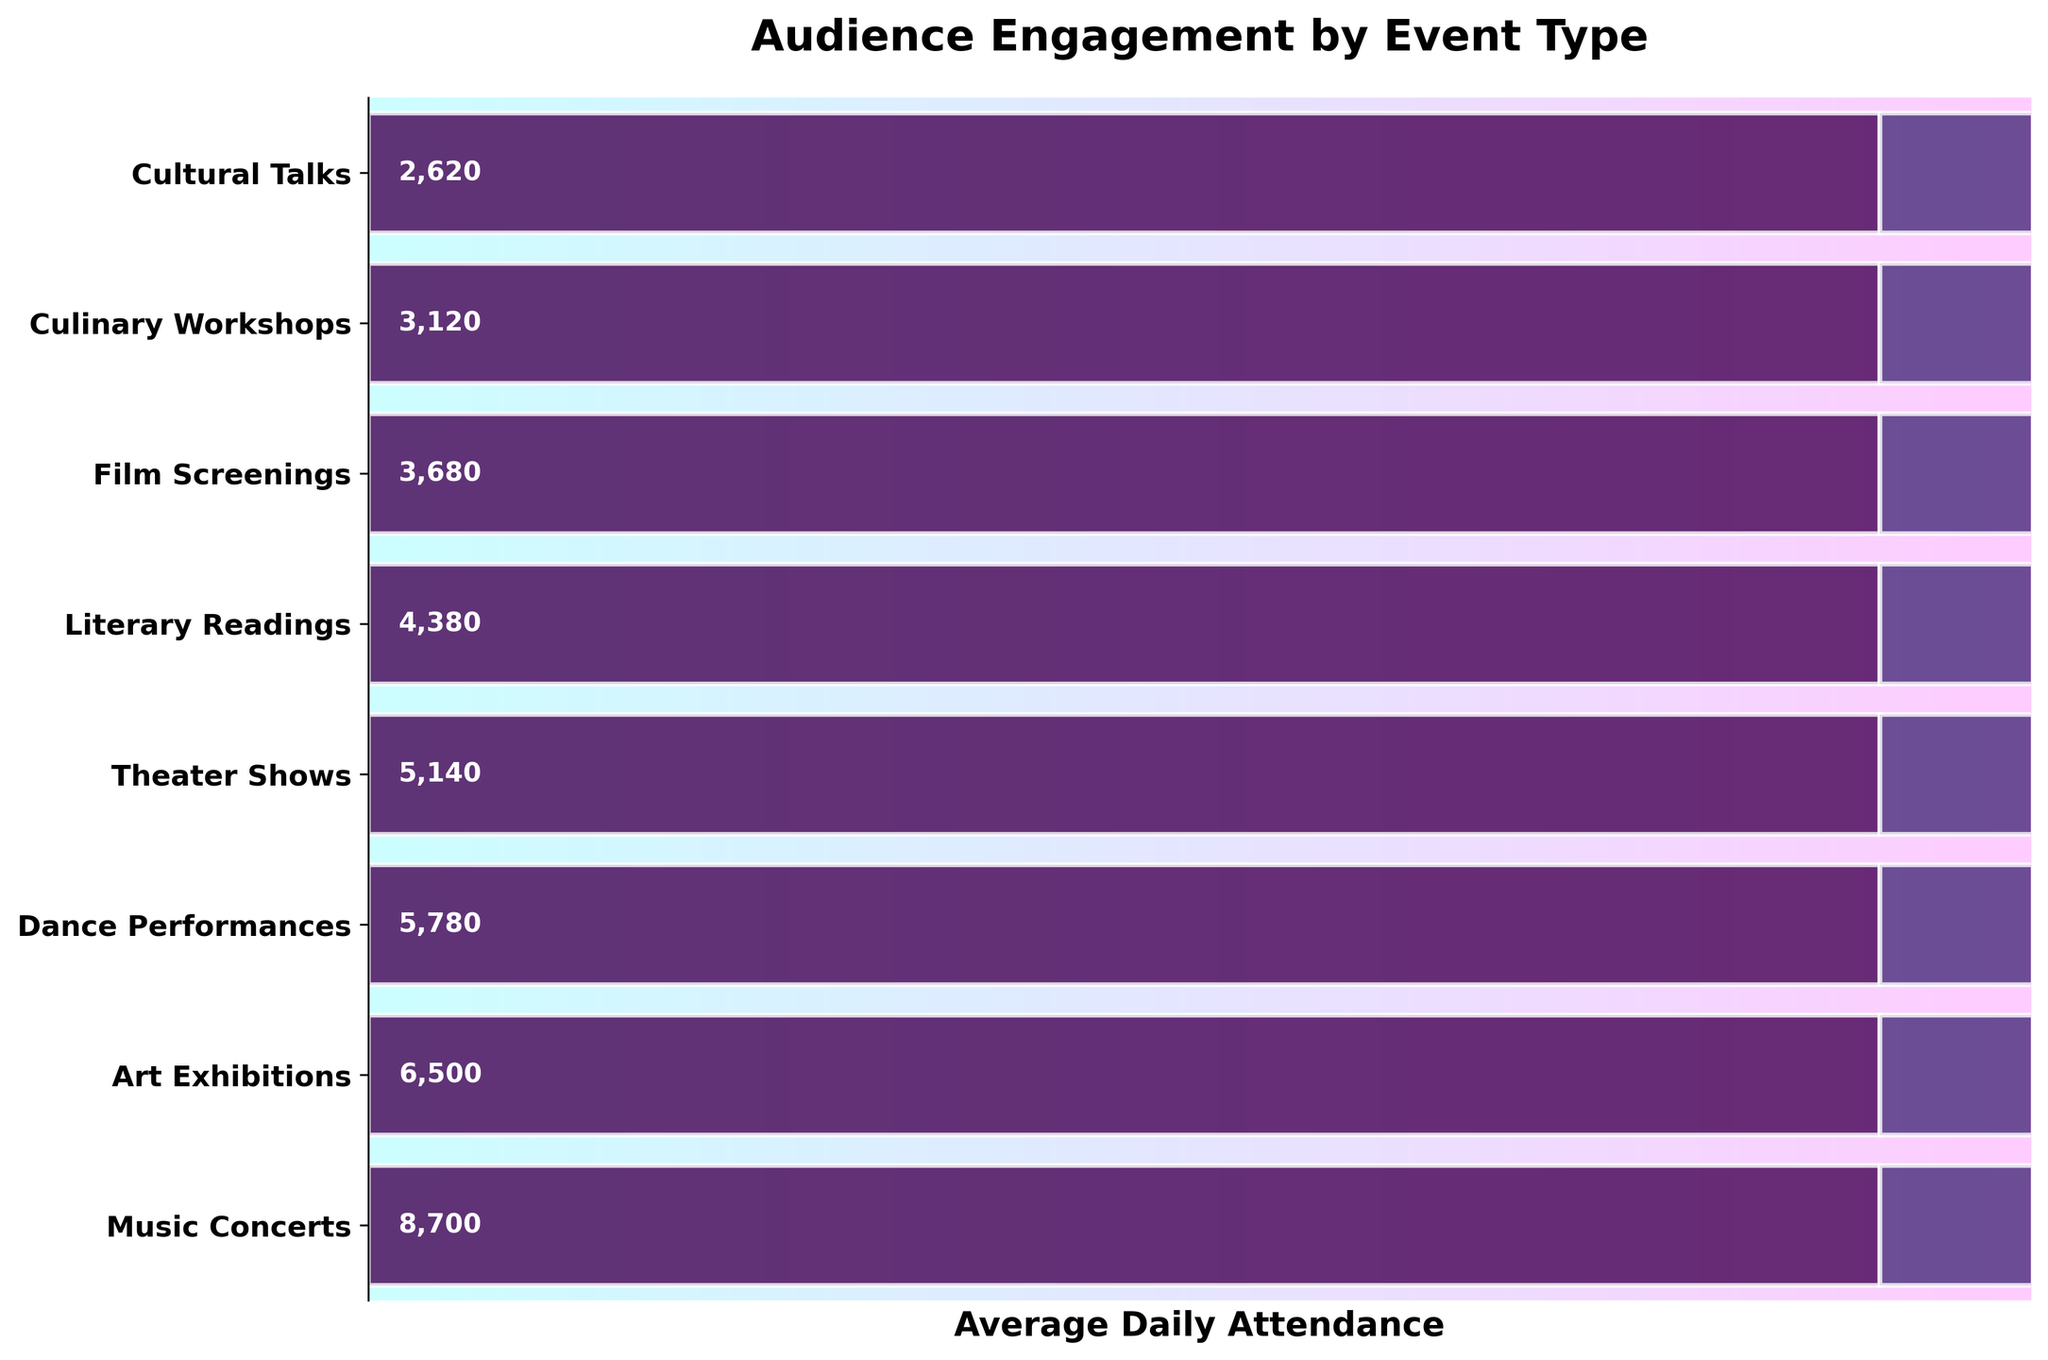How many y-axis labels are there on the plot? The y-axis labels correspond to the various event types listed in the data. There are eight event types in the dataset.
Answer: 8 What is the title of the funnel chart? The title is displayed prominently at the top of the chart. It states the main subject of the chart.
Answer: Audience Engagement by Event Type Which event type had the highest average daily attendance? The highest average daily attendance can be identified by the longest bar in the funnel chart.
Answer: Music Concerts Which event type had the lowest average daily attendance? The lowest average daily attendance can be identified by the shortest bar in the funnel chart.
Answer: Cultural Talks What is the average attendance for Art Exhibitions across the festival? The value for Art Exhibitions is displayed along the bar corresponding to Art Exhibitions.
Answer: 6,600 How does the average daily attendance for Theater Shows compare to Dance Performances? By comparing the lengths of the bars for Theater Shows and Dance Performances, we observe which one is shorter.
Answer: Theater Shows have lower attendance What is the total attendance for Literary Readings on Day 3 and Day 4 combined? Sum the attendance for Literary Readings on Day 3 and Day 4 from the data provided.
Answer: 7,700 By what percentage does the attendance for Film Screenings on Day 5 decrease compared to Day 1? Calculate the percentage decrease: ((Attendance on Day 1 - Attendance on Day 5) / Attendance on Day 1) * 100
Answer: 2.35% Are there any event types whose average daily attendance is above 8,000? If so, which ones? Identify the event types with a bar length representing an average above 8,000.
Answer: Only Music Concerts Which day had the highest attendance for Culinary Workshops? The day with the highest attendance will be the one with the highest value in the Culinary Workshops row.
Answer: Day 3 